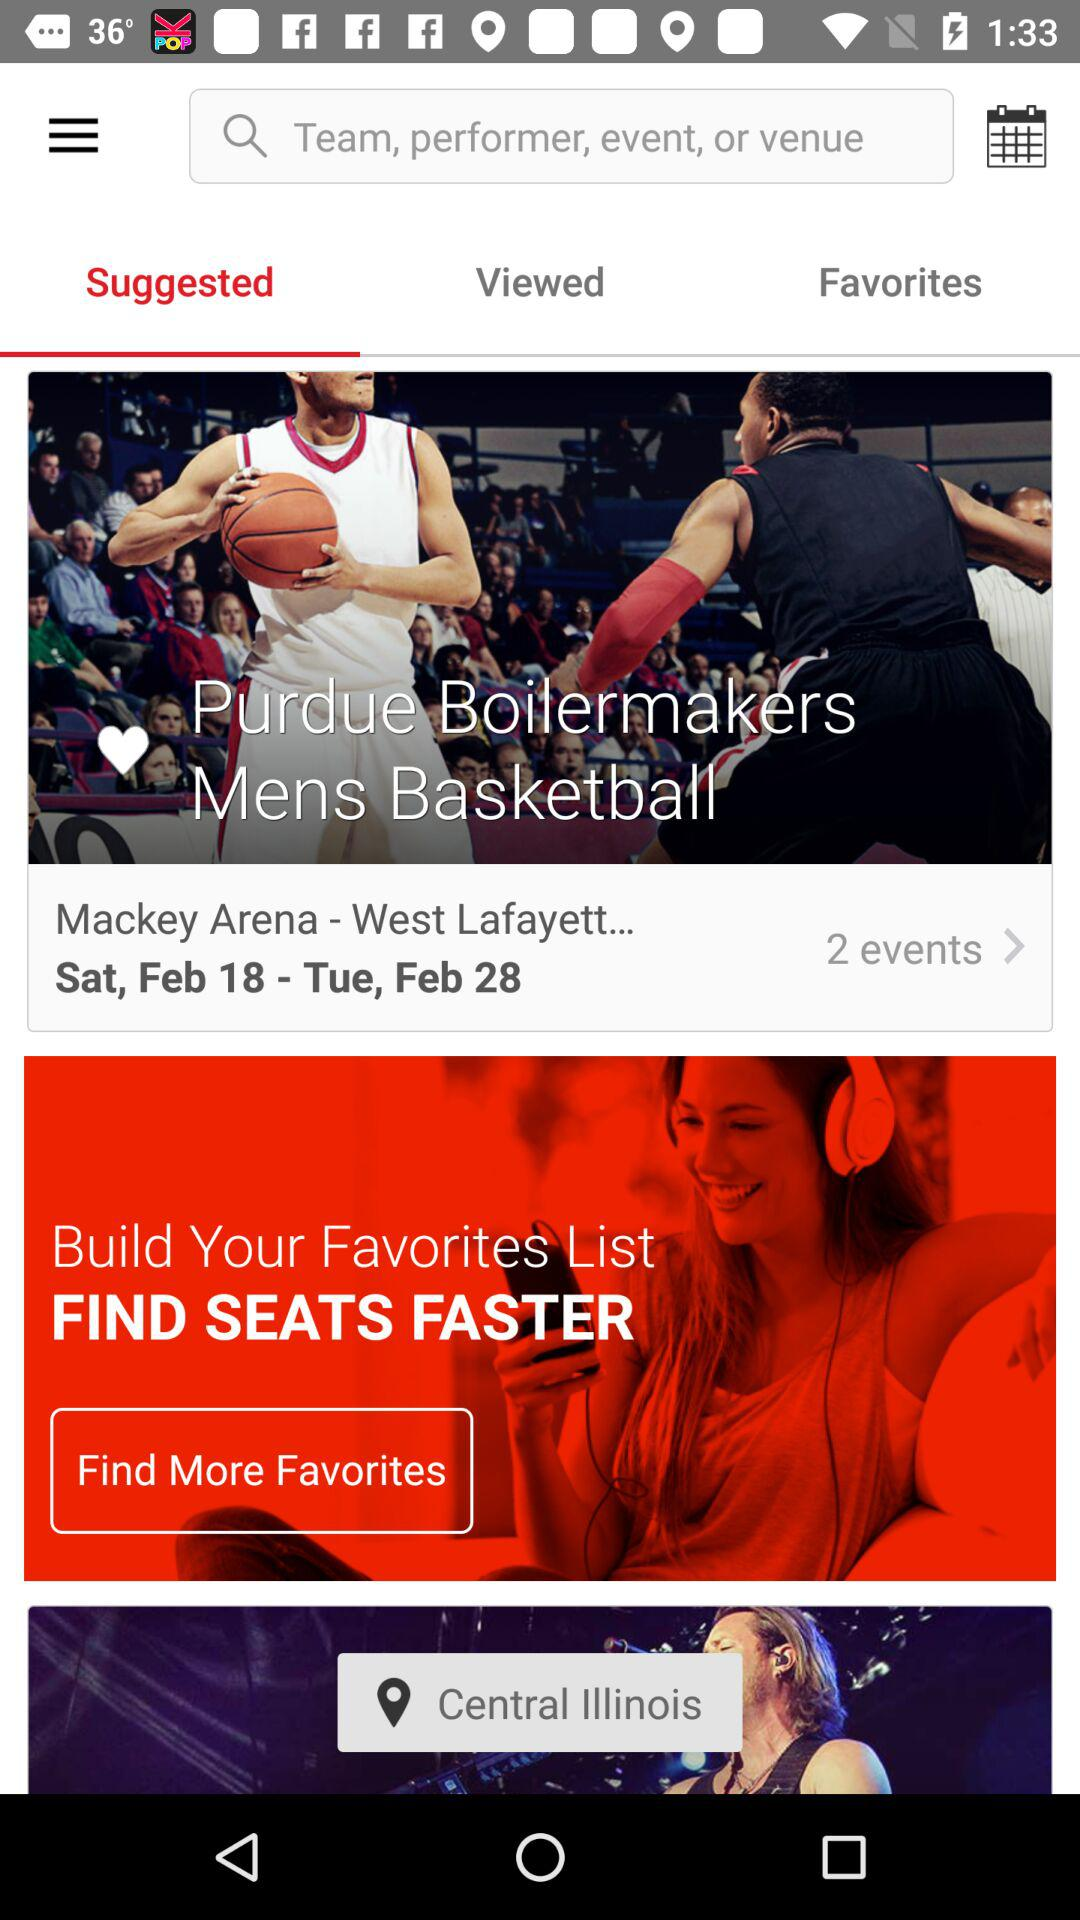Which day is on 18 February? The day on February 18 is Saturday. 